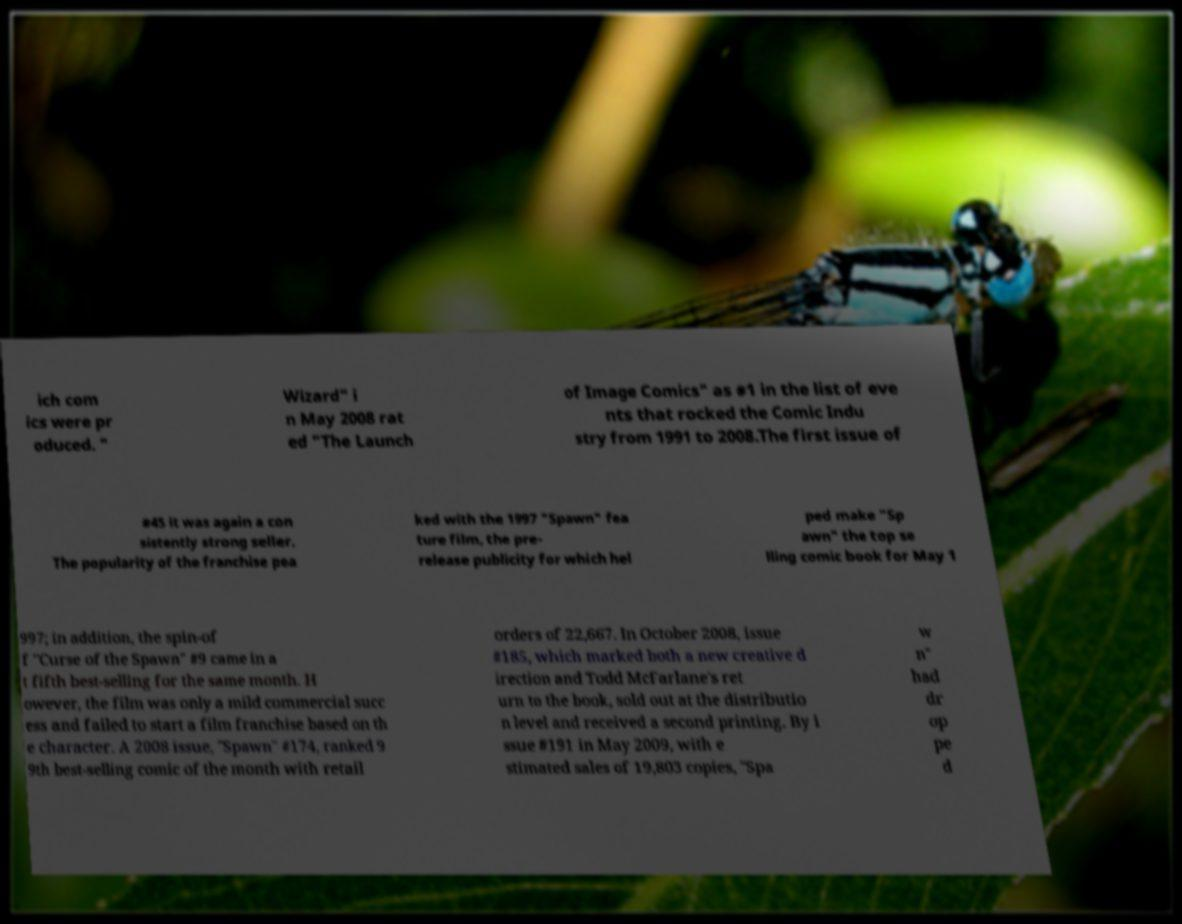Please read and relay the text visible in this image. What does it say? ich com ics were pr oduced. " Wizard" i n May 2008 rat ed "The Launch of Image Comics" as #1 in the list of eve nts that rocked the Comic Indu stry from 1991 to 2008.The first issue of #45 it was again a con sistently strong seller. The popularity of the franchise pea ked with the 1997 "Spawn" fea ture film, the pre- release publicity for which hel ped make "Sp awn" the top se lling comic book for May 1 997; in addition, the spin-of f "Curse of the Spawn" #9 came in a t fifth best-selling for the same month. H owever, the film was only a mild commercial succ ess and failed to start a film franchise based on th e character. A 2008 issue, "Spawn" #174, ranked 9 9th best-selling comic of the month with retail orders of 22,667. In October 2008, issue #185, which marked both a new creative d irection and Todd McFarlane's ret urn to the book, sold out at the distributio n level and received a second printing. By i ssue #191 in May 2009, with e stimated sales of 19,803 copies, "Spa w n" had dr op pe d 